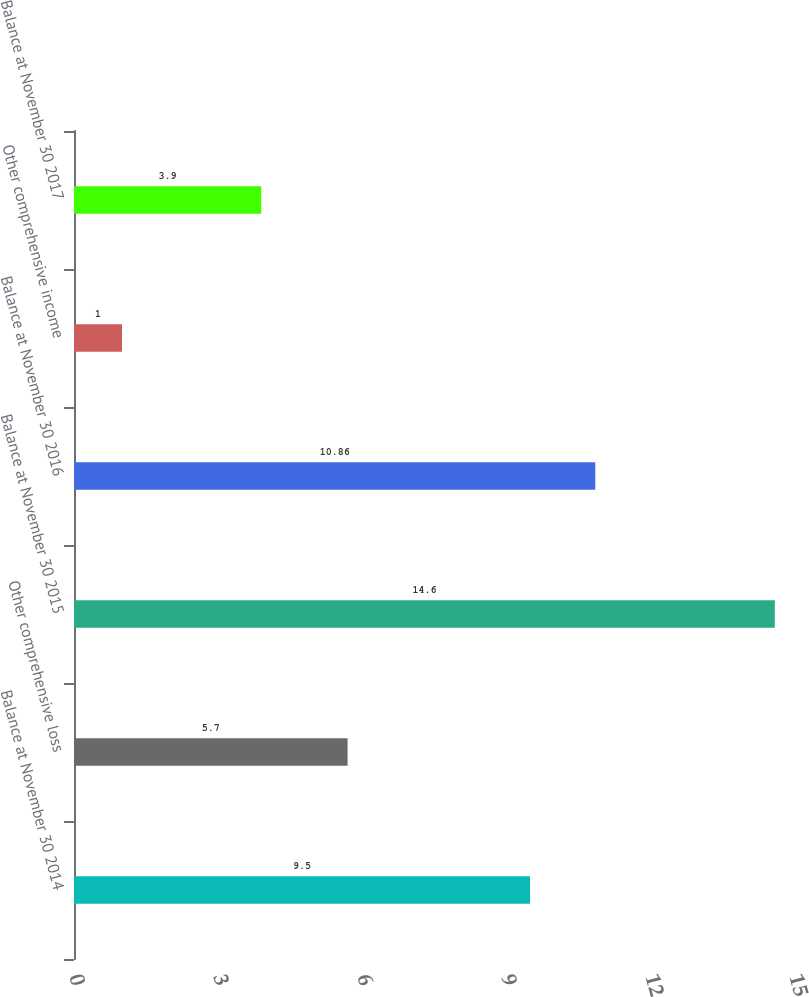Convert chart. <chart><loc_0><loc_0><loc_500><loc_500><bar_chart><fcel>Balance at November 30 2014<fcel>Other comprehensive loss<fcel>Balance at November 30 2015<fcel>Balance at November 30 2016<fcel>Other comprehensive income<fcel>Balance at November 30 2017<nl><fcel>9.5<fcel>5.7<fcel>14.6<fcel>10.86<fcel>1<fcel>3.9<nl></chart> 